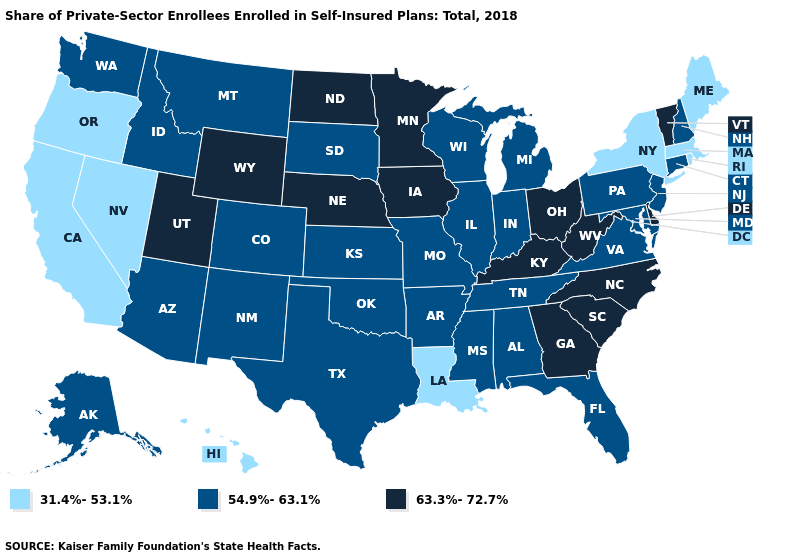What is the value of Oklahoma?
Write a very short answer. 54.9%-63.1%. Which states have the lowest value in the USA?
Write a very short answer. California, Hawaii, Louisiana, Maine, Massachusetts, Nevada, New York, Oregon, Rhode Island. What is the highest value in the West ?
Keep it brief. 63.3%-72.7%. What is the highest value in states that border Oregon?
Quick response, please. 54.9%-63.1%. What is the value of Arkansas?
Write a very short answer. 54.9%-63.1%. What is the value of Kansas?
Concise answer only. 54.9%-63.1%. What is the lowest value in the USA?
Be succinct. 31.4%-53.1%. Does Minnesota have the same value as Connecticut?
Write a very short answer. No. Among the states that border Rhode Island , which have the highest value?
Write a very short answer. Connecticut. What is the value of Virginia?
Be succinct. 54.9%-63.1%. Does Arkansas have the lowest value in the USA?
Answer briefly. No. Name the states that have a value in the range 31.4%-53.1%?
Be succinct. California, Hawaii, Louisiana, Maine, Massachusetts, Nevada, New York, Oregon, Rhode Island. What is the value of Alaska?
Give a very brief answer. 54.9%-63.1%. What is the value of Kentucky?
Be succinct. 63.3%-72.7%. What is the value of Alabama?
Be succinct. 54.9%-63.1%. 